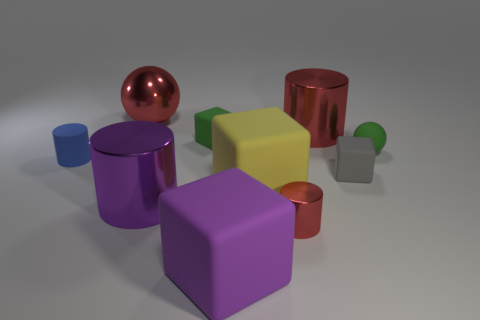There is a green matte thing that is to the left of the small matte ball; does it have the same shape as the rubber thing in front of the yellow matte thing?
Keep it short and to the point. Yes. How many other things are the same material as the small blue cylinder?
Ensure brevity in your answer.  5. There is a ball behind the small green object to the left of the purple rubber block; are there any large purple rubber objects in front of it?
Keep it short and to the point. Yes. Is the material of the small blue cylinder the same as the gray block?
Give a very brief answer. Yes. Is there any other thing that has the same shape as the big purple metallic object?
Give a very brief answer. Yes. The small green object that is on the right side of the tiny cylinder that is on the right side of the red sphere is made of what material?
Your answer should be compact. Rubber. What size is the cylinder that is to the left of the red metal ball?
Provide a succinct answer. Small. The cube that is both on the left side of the big yellow cube and behind the purple rubber block is what color?
Make the answer very short. Green. Do the red object that is in front of the yellow rubber object and the small blue matte cylinder have the same size?
Provide a short and direct response. Yes. There is a small green object on the left side of the green sphere; are there any tiny matte objects behind it?
Provide a succinct answer. No. 